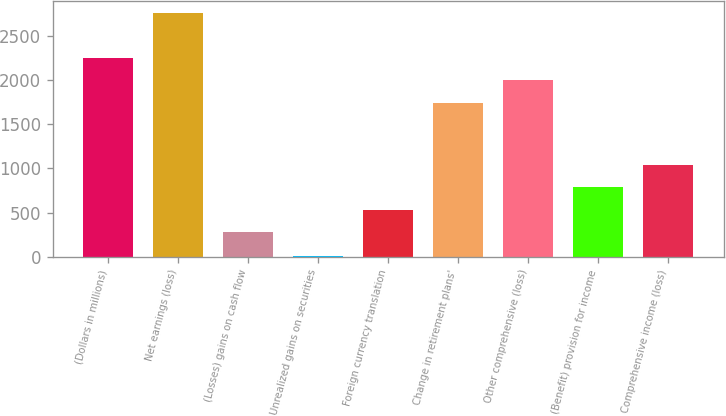<chart> <loc_0><loc_0><loc_500><loc_500><bar_chart><fcel>(Dollars in millions)<fcel>Net earnings (loss)<fcel>(Losses) gains on cash flow<fcel>Unrealized gains on securities<fcel>Foreign currency translation<fcel>Change in retirement plans'<fcel>Other comprehensive (loss)<fcel>(Benefit) provision for income<fcel>Comprehensive income (loss)<nl><fcel>2249.6<fcel>2754.2<fcel>279<fcel>10<fcel>531.3<fcel>1745<fcel>1997.3<fcel>783.6<fcel>1035.9<nl></chart> 